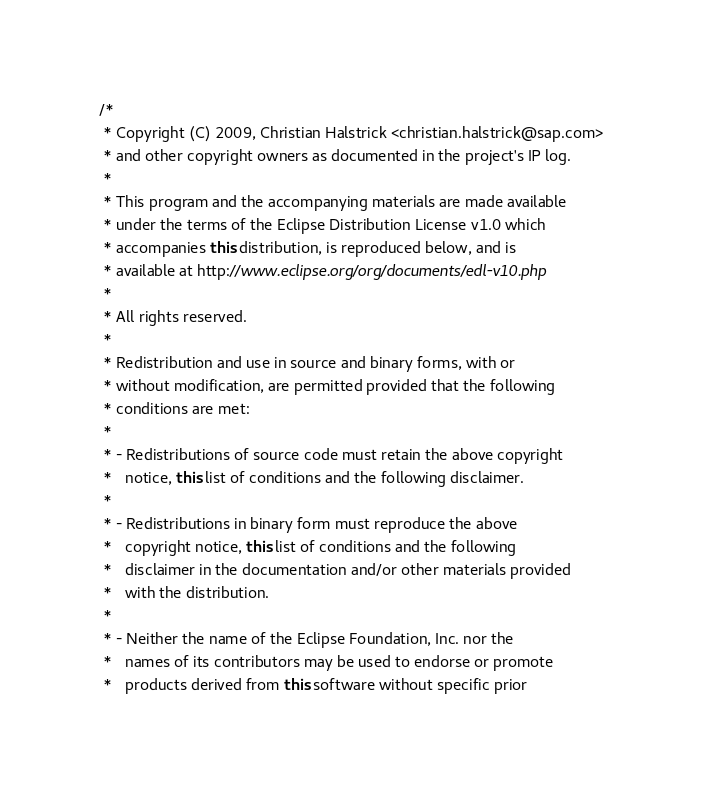<code> <loc_0><loc_0><loc_500><loc_500><_Java_>/*
 * Copyright (C) 2009, Christian Halstrick <christian.halstrick@sap.com>
 * and other copyright owners as documented in the project's IP log.
 *
 * This program and the accompanying materials are made available
 * under the terms of the Eclipse Distribution License v1.0 which
 * accompanies this distribution, is reproduced below, and is
 * available at http://www.eclipse.org/org/documents/edl-v10.php
 *
 * All rights reserved.
 *
 * Redistribution and use in source and binary forms, with or
 * without modification, are permitted provided that the following
 * conditions are met:
 *
 * - Redistributions of source code must retain the above copyright
 *   notice, this list of conditions and the following disclaimer.
 *
 * - Redistributions in binary form must reproduce the above
 *   copyright notice, this list of conditions and the following
 *   disclaimer in the documentation and/or other materials provided
 *   with the distribution.
 *
 * - Neither the name of the Eclipse Foundation, Inc. nor the
 *   names of its contributors may be used to endorse or promote
 *   products derived from this software without specific prior</code> 